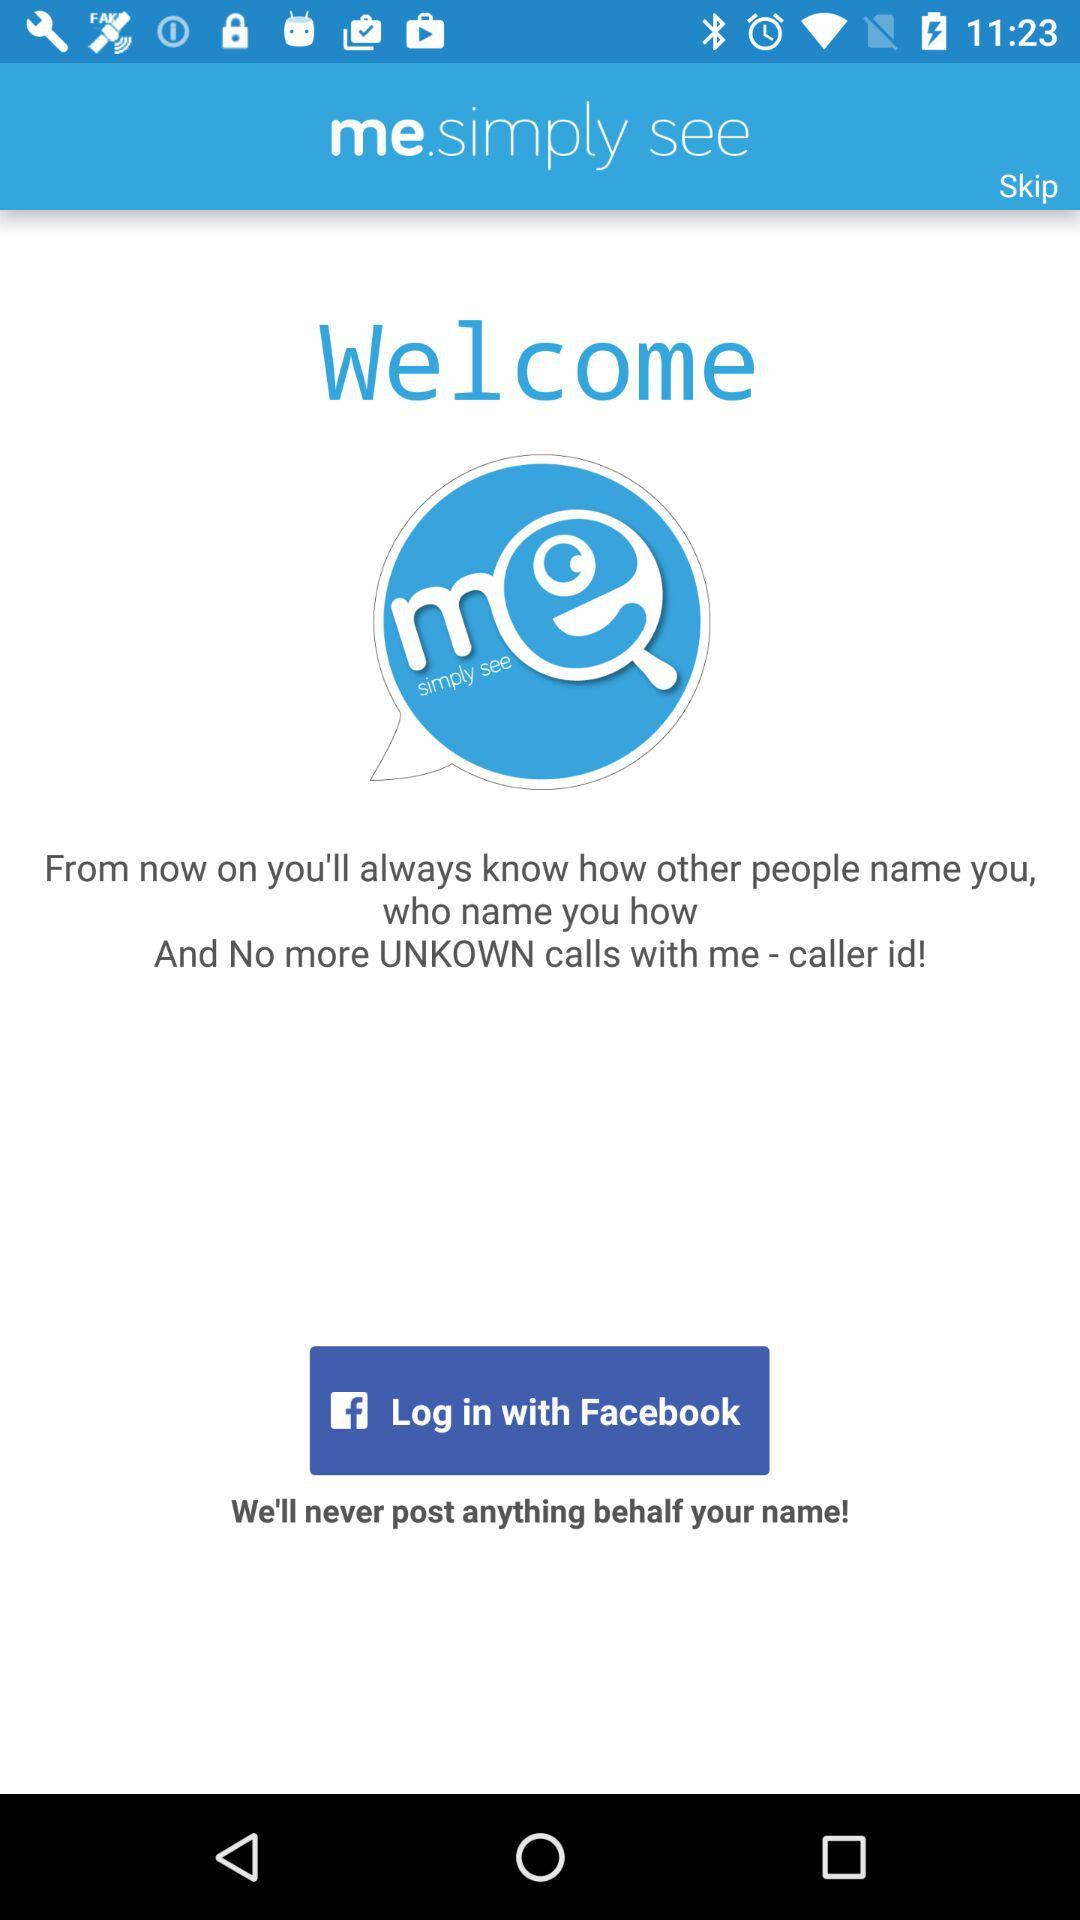What is the app name? The app name is "me.simply see". 